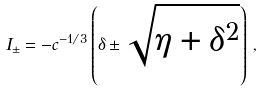Convert formula to latex. <formula><loc_0><loc_0><loc_500><loc_500>I _ { \pm } = - c ^ { - 1 / 3 } \left ( \delta \pm \sqrt { \eta + \delta ^ { 2 } } \right ) \, ,</formula> 